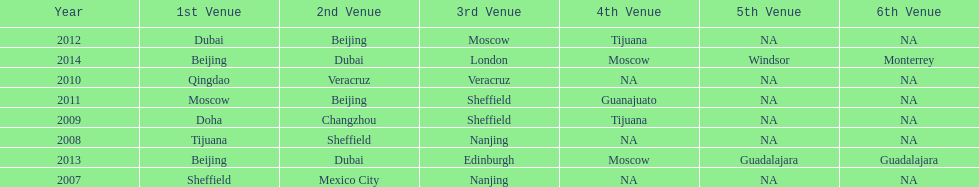Help me parse the entirety of this table. {'header': ['Year', '1st Venue', '2nd Venue', '3rd Venue', '4th Venue', '5th Venue', '6th Venue'], 'rows': [['2012', 'Dubai', 'Beijing', 'Moscow', 'Tijuana', 'NA', 'NA'], ['2014', 'Beijing', 'Dubai', 'London', 'Moscow', 'Windsor', 'Monterrey'], ['2010', 'Qingdao', 'Veracruz', 'Veracruz', 'NA', 'NA', 'NA'], ['2011', 'Moscow', 'Beijing', 'Sheffield', 'Guanajuato', 'NA', 'NA'], ['2009', 'Doha', 'Changzhou', 'Sheffield', 'Tijuana', 'NA', 'NA'], ['2008', 'Tijuana', 'Sheffield', 'Nanjing', 'NA', 'NA', 'NA'], ['2013', 'Beijing', 'Dubai', 'Edinburgh', 'Moscow', 'Guadalajara', 'Guadalajara'], ['2007', 'Sheffield', 'Mexico City', 'Nanjing', 'NA', 'NA', 'NA']]} Which year had more venues, 2007 or 2012? 2012. 